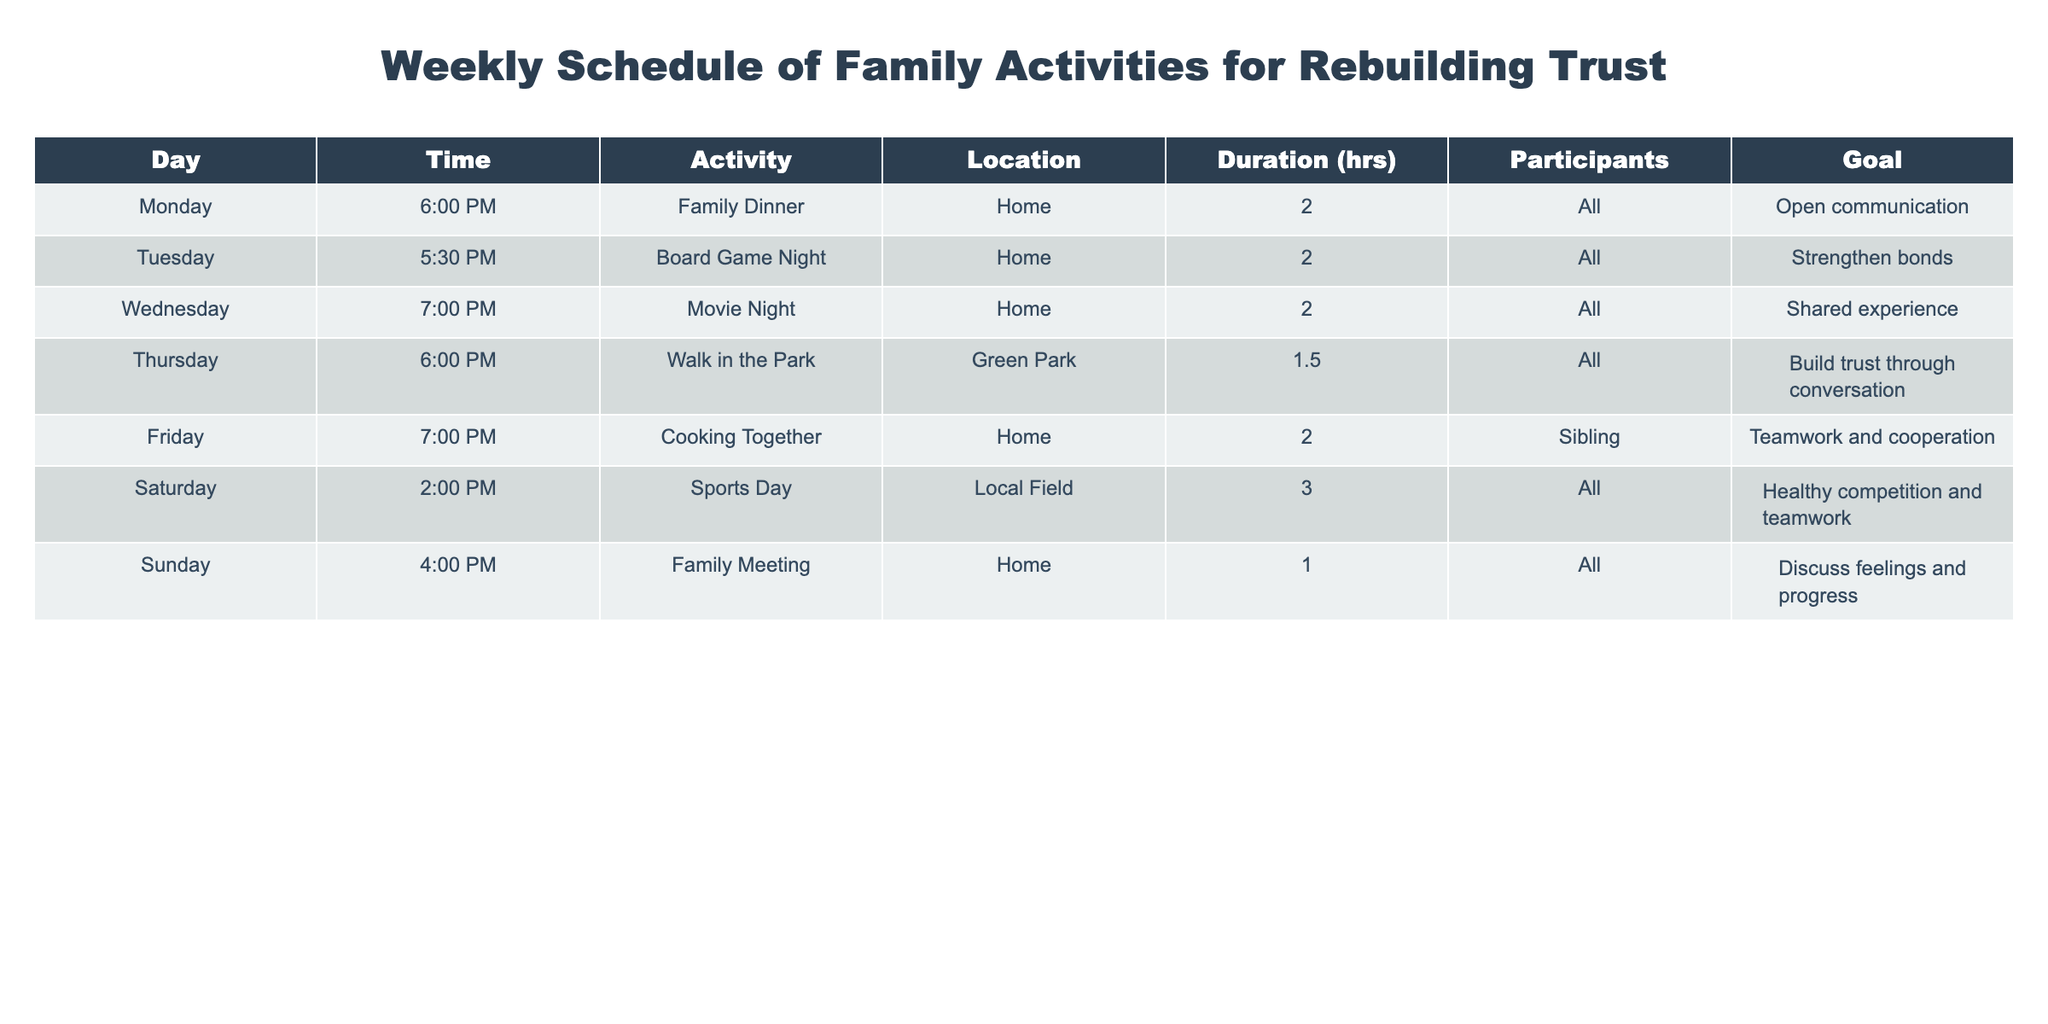What is the activity scheduled for Tuesday? Referring to the table, on Tuesday the activity listed is "Board Game Night."
Answer: Board Game Night How long is the Family Dinner scheduled to last? According to the table, the duration for Family Dinner on Monday is specified as 2 hours.
Answer: 2 hours Which activity is scheduled for Sunday? The table indicates that on Sunday the activity is "Family Meeting."
Answer: Family Meeting What is the total duration of activities scheduled for the whole week? To find the total duration, we sum the duration of each activity: 2 + 2 + 2 + 1.5 + 2 + 3 + 1 = 14.5 hours.
Answer: 14.5 hours Is there an activity that only includes siblings as participants? Looking at the participants' column, the only activity that includes just siblings is "Cooking Together" on Friday.
Answer: Yes Which activity has the goal of "Strengthen bonds"? From the table, the activity with the goal of "Strengthen bonds" is scheduled for Tuesday, which is "Board Game Night."
Answer: Board Game Night What is the average duration of activities scheduled during the week? To calculate the average, sum the durations: 2 + 2 + 2 + 1.5 + 2 + 3 + 1 = 14.5. There are 7 activities, so the average duration is 14.5 / 7 = approximately 2.07 hours.
Answer: 2.07 hours On which day is the goal "Discuss feelings and progress" set? The table shows that the activity with the goal to "Discuss feelings and progress" is scheduled for Sunday during the "Family Meeting."
Answer: Sunday Is "Walk in the Park" open to all participants? Checking the participants' column, the "Walk in the Park" activity on Thursday includes "All," meaning everyone can participate.
Answer: Yes 